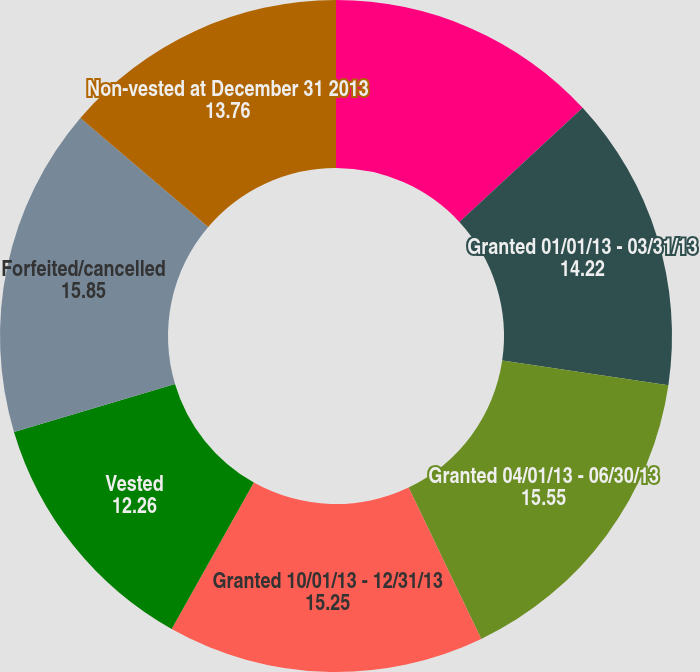Convert chart. <chart><loc_0><loc_0><loc_500><loc_500><pie_chart><fcel>Non-vested at January 1 2013<fcel>Granted 01/01/13 - 03/31/13<fcel>Granted 04/01/13 - 06/30/13<fcel>Granted 10/01/13 - 12/31/13<fcel>Vested<fcel>Forfeited/cancelled<fcel>Non-vested at December 31 2013<nl><fcel>13.12%<fcel>14.22%<fcel>15.55%<fcel>15.25%<fcel>12.26%<fcel>15.85%<fcel>13.76%<nl></chart> 